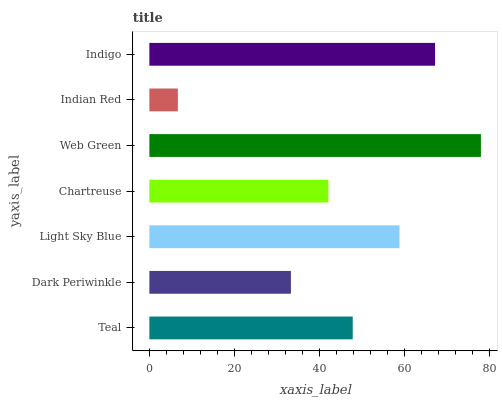Is Indian Red the minimum?
Answer yes or no. Yes. Is Web Green the maximum?
Answer yes or no. Yes. Is Dark Periwinkle the minimum?
Answer yes or no. No. Is Dark Periwinkle the maximum?
Answer yes or no. No. Is Teal greater than Dark Periwinkle?
Answer yes or no. Yes. Is Dark Periwinkle less than Teal?
Answer yes or no. Yes. Is Dark Periwinkle greater than Teal?
Answer yes or no. No. Is Teal less than Dark Periwinkle?
Answer yes or no. No. Is Teal the high median?
Answer yes or no. Yes. Is Teal the low median?
Answer yes or no. Yes. Is Indigo the high median?
Answer yes or no. No. Is Indian Red the low median?
Answer yes or no. No. 